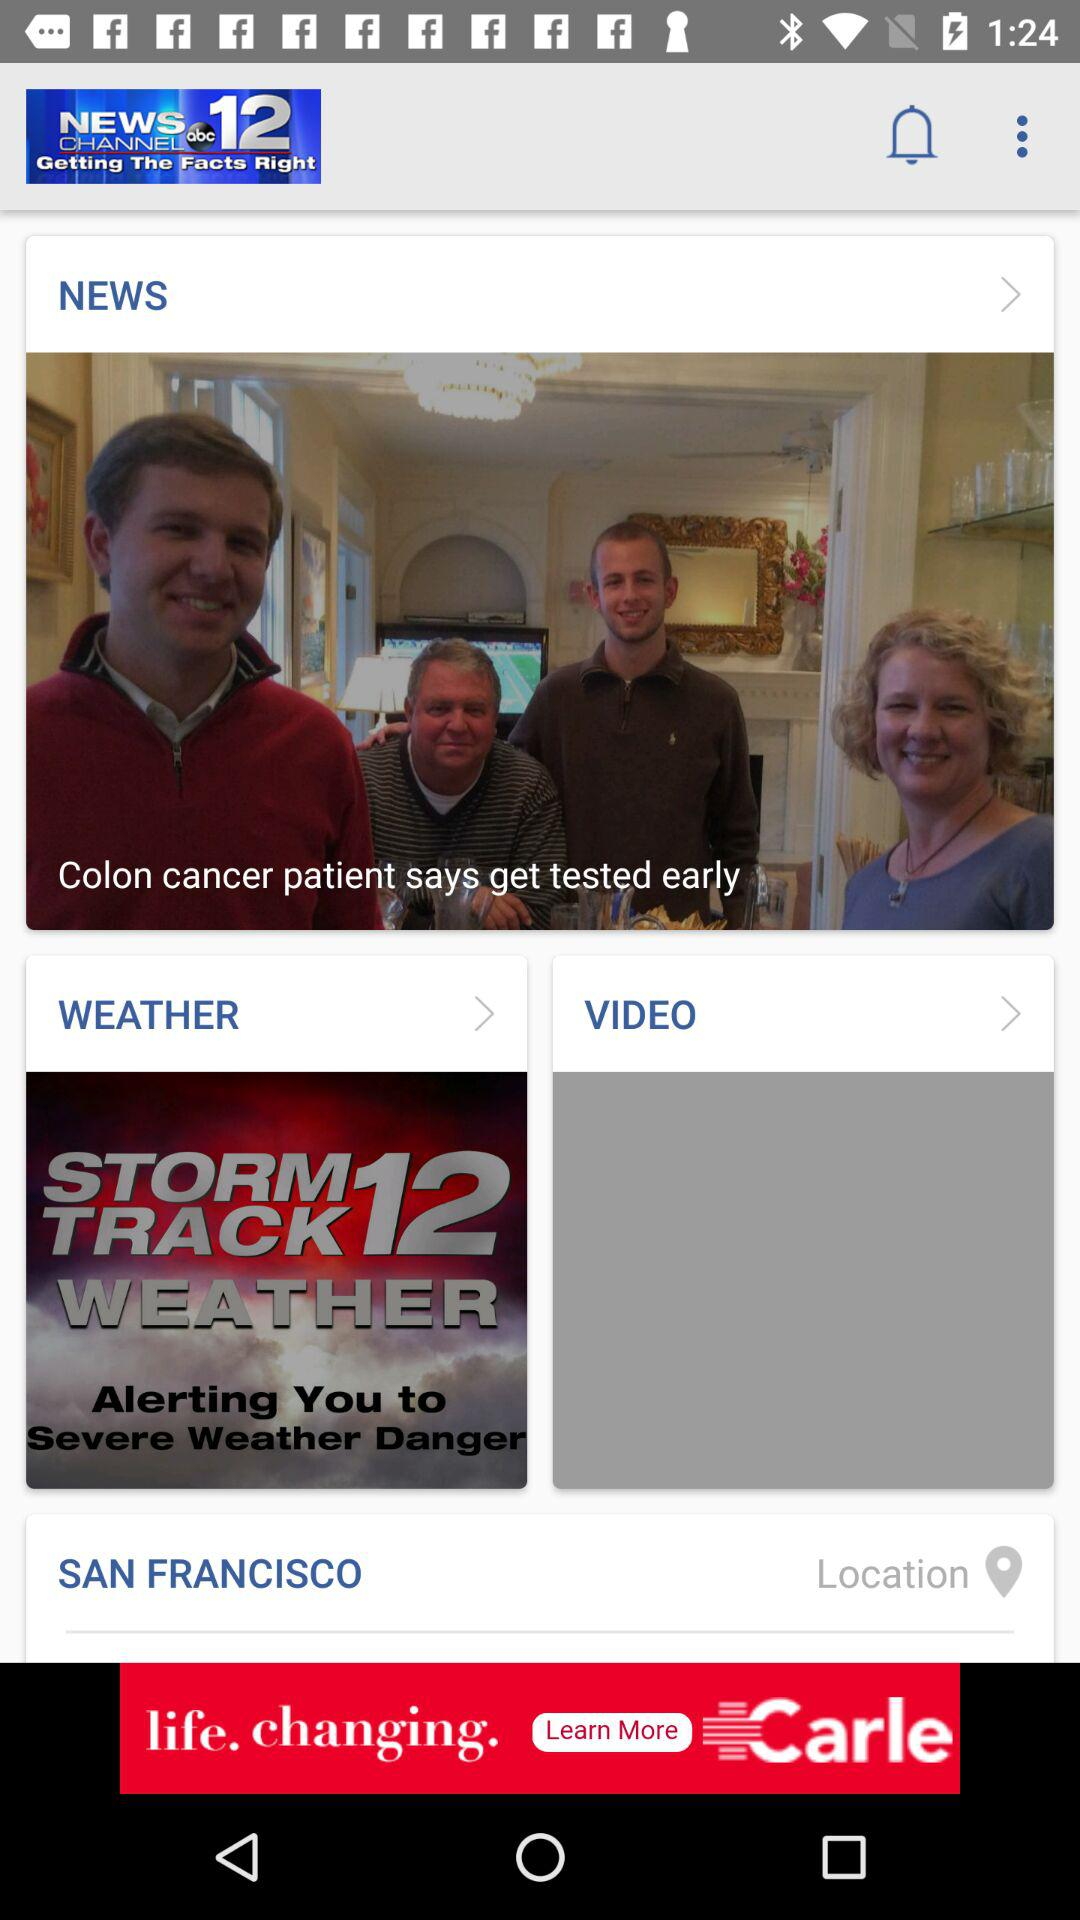What is the location? The location is San Francisco. 